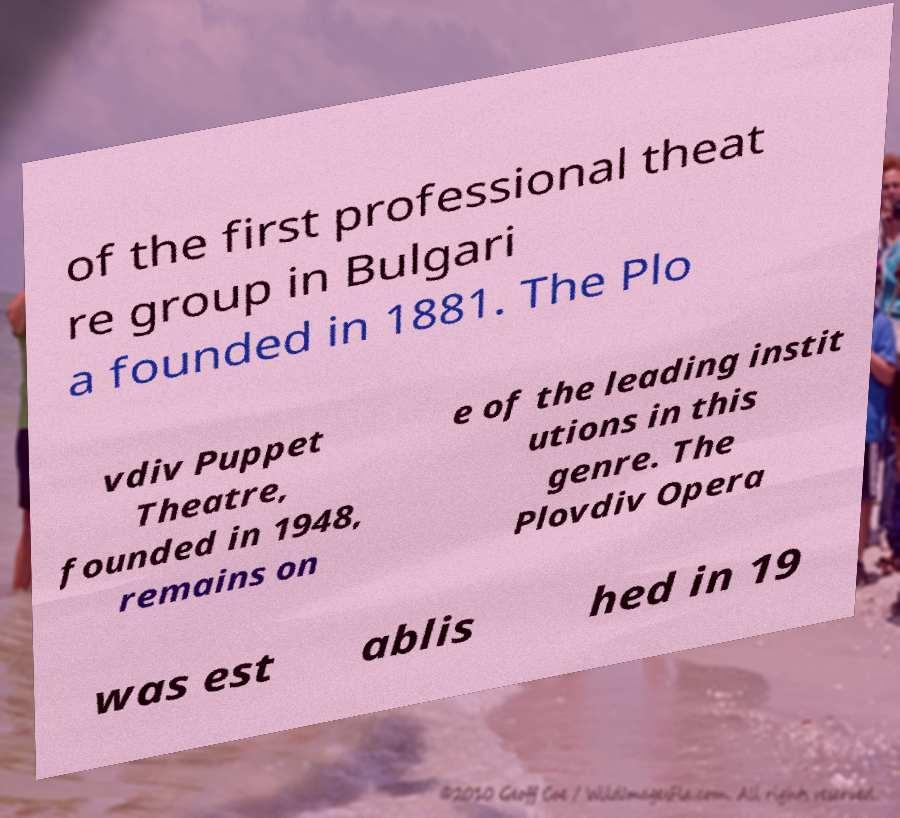I need the written content from this picture converted into text. Can you do that? of the first professional theat re group in Bulgari a founded in 1881. The Plo vdiv Puppet Theatre, founded in 1948, remains on e of the leading instit utions in this genre. The Plovdiv Opera was est ablis hed in 19 